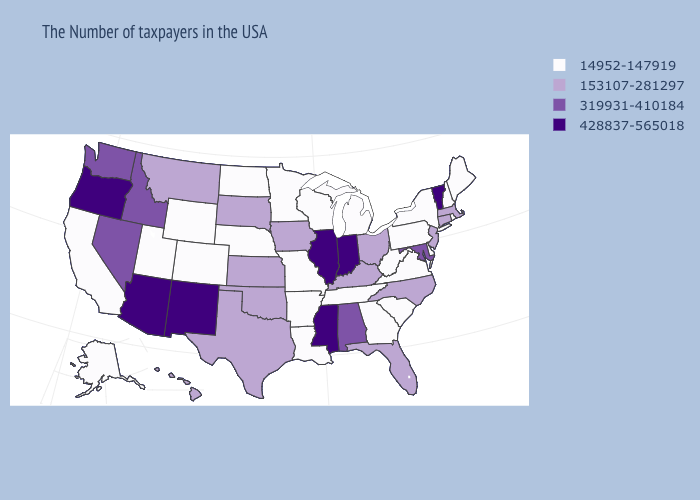What is the highest value in the USA?
Quick response, please. 428837-565018. What is the value of South Dakota?
Give a very brief answer. 153107-281297. Which states have the highest value in the USA?
Write a very short answer. Vermont, Indiana, Illinois, Mississippi, New Mexico, Arizona, Oregon. Name the states that have a value in the range 428837-565018?
Answer briefly. Vermont, Indiana, Illinois, Mississippi, New Mexico, Arizona, Oregon. Name the states that have a value in the range 14952-147919?
Quick response, please. Maine, Rhode Island, New Hampshire, New York, Delaware, Pennsylvania, Virginia, South Carolina, West Virginia, Georgia, Michigan, Tennessee, Wisconsin, Louisiana, Missouri, Arkansas, Minnesota, Nebraska, North Dakota, Wyoming, Colorado, Utah, California, Alaska. What is the lowest value in the USA?
Be succinct. 14952-147919. Name the states that have a value in the range 428837-565018?
Quick response, please. Vermont, Indiana, Illinois, Mississippi, New Mexico, Arizona, Oregon. What is the value of Alabama?
Quick response, please. 319931-410184. Does Mississippi have a higher value than Nevada?
Give a very brief answer. Yes. How many symbols are there in the legend?
Concise answer only. 4. Does Michigan have the highest value in the USA?
Concise answer only. No. Does Hawaii have the same value as Colorado?
Give a very brief answer. No. Name the states that have a value in the range 428837-565018?
Write a very short answer. Vermont, Indiana, Illinois, Mississippi, New Mexico, Arizona, Oregon. What is the highest value in the USA?
Be succinct. 428837-565018. Does the first symbol in the legend represent the smallest category?
Keep it brief. Yes. 